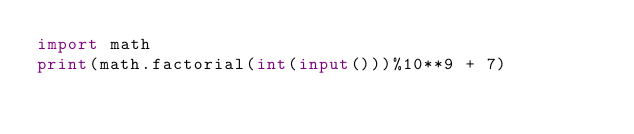<code> <loc_0><loc_0><loc_500><loc_500><_Python_>import math
print(math.factorial(int(input()))%10**9 + 7)</code> 